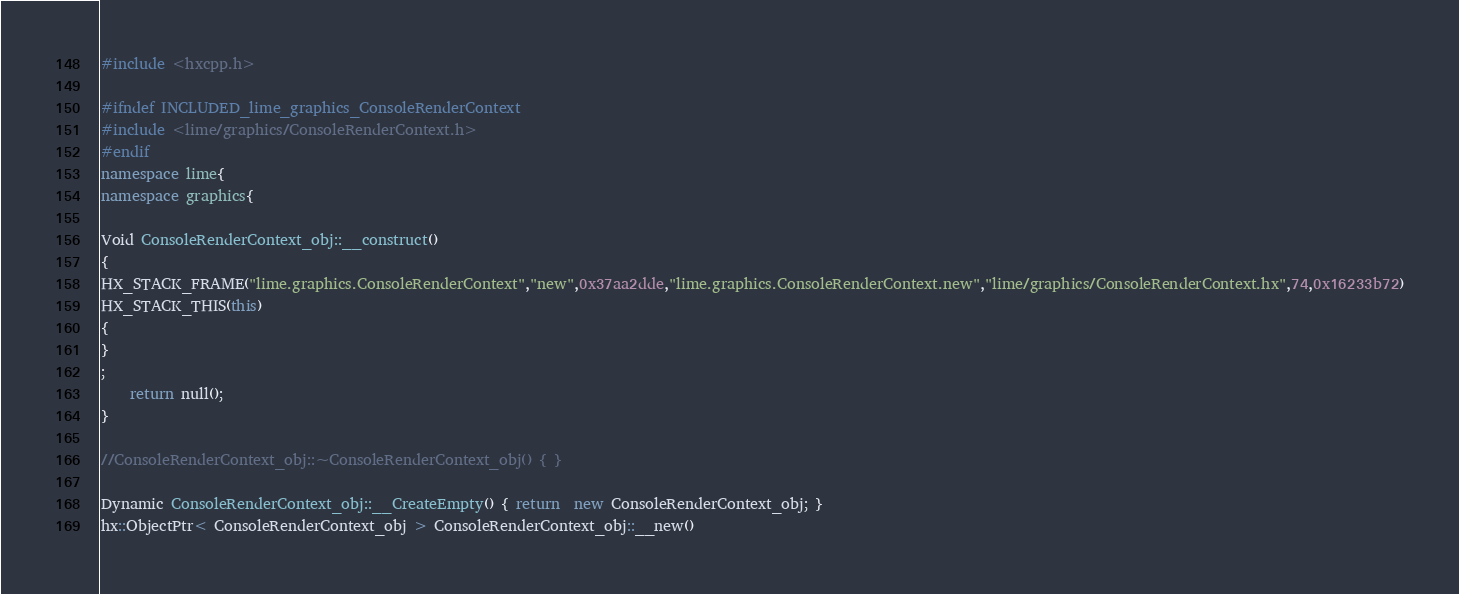<code> <loc_0><loc_0><loc_500><loc_500><_C++_>#include <hxcpp.h>

#ifndef INCLUDED_lime_graphics_ConsoleRenderContext
#include <lime/graphics/ConsoleRenderContext.h>
#endif
namespace lime{
namespace graphics{

Void ConsoleRenderContext_obj::__construct()
{
HX_STACK_FRAME("lime.graphics.ConsoleRenderContext","new",0x37aa2dde,"lime.graphics.ConsoleRenderContext.new","lime/graphics/ConsoleRenderContext.hx",74,0x16233b72)
HX_STACK_THIS(this)
{
}
;
	return null();
}

//ConsoleRenderContext_obj::~ConsoleRenderContext_obj() { }

Dynamic ConsoleRenderContext_obj::__CreateEmpty() { return  new ConsoleRenderContext_obj; }
hx::ObjectPtr< ConsoleRenderContext_obj > ConsoleRenderContext_obj::__new()</code> 